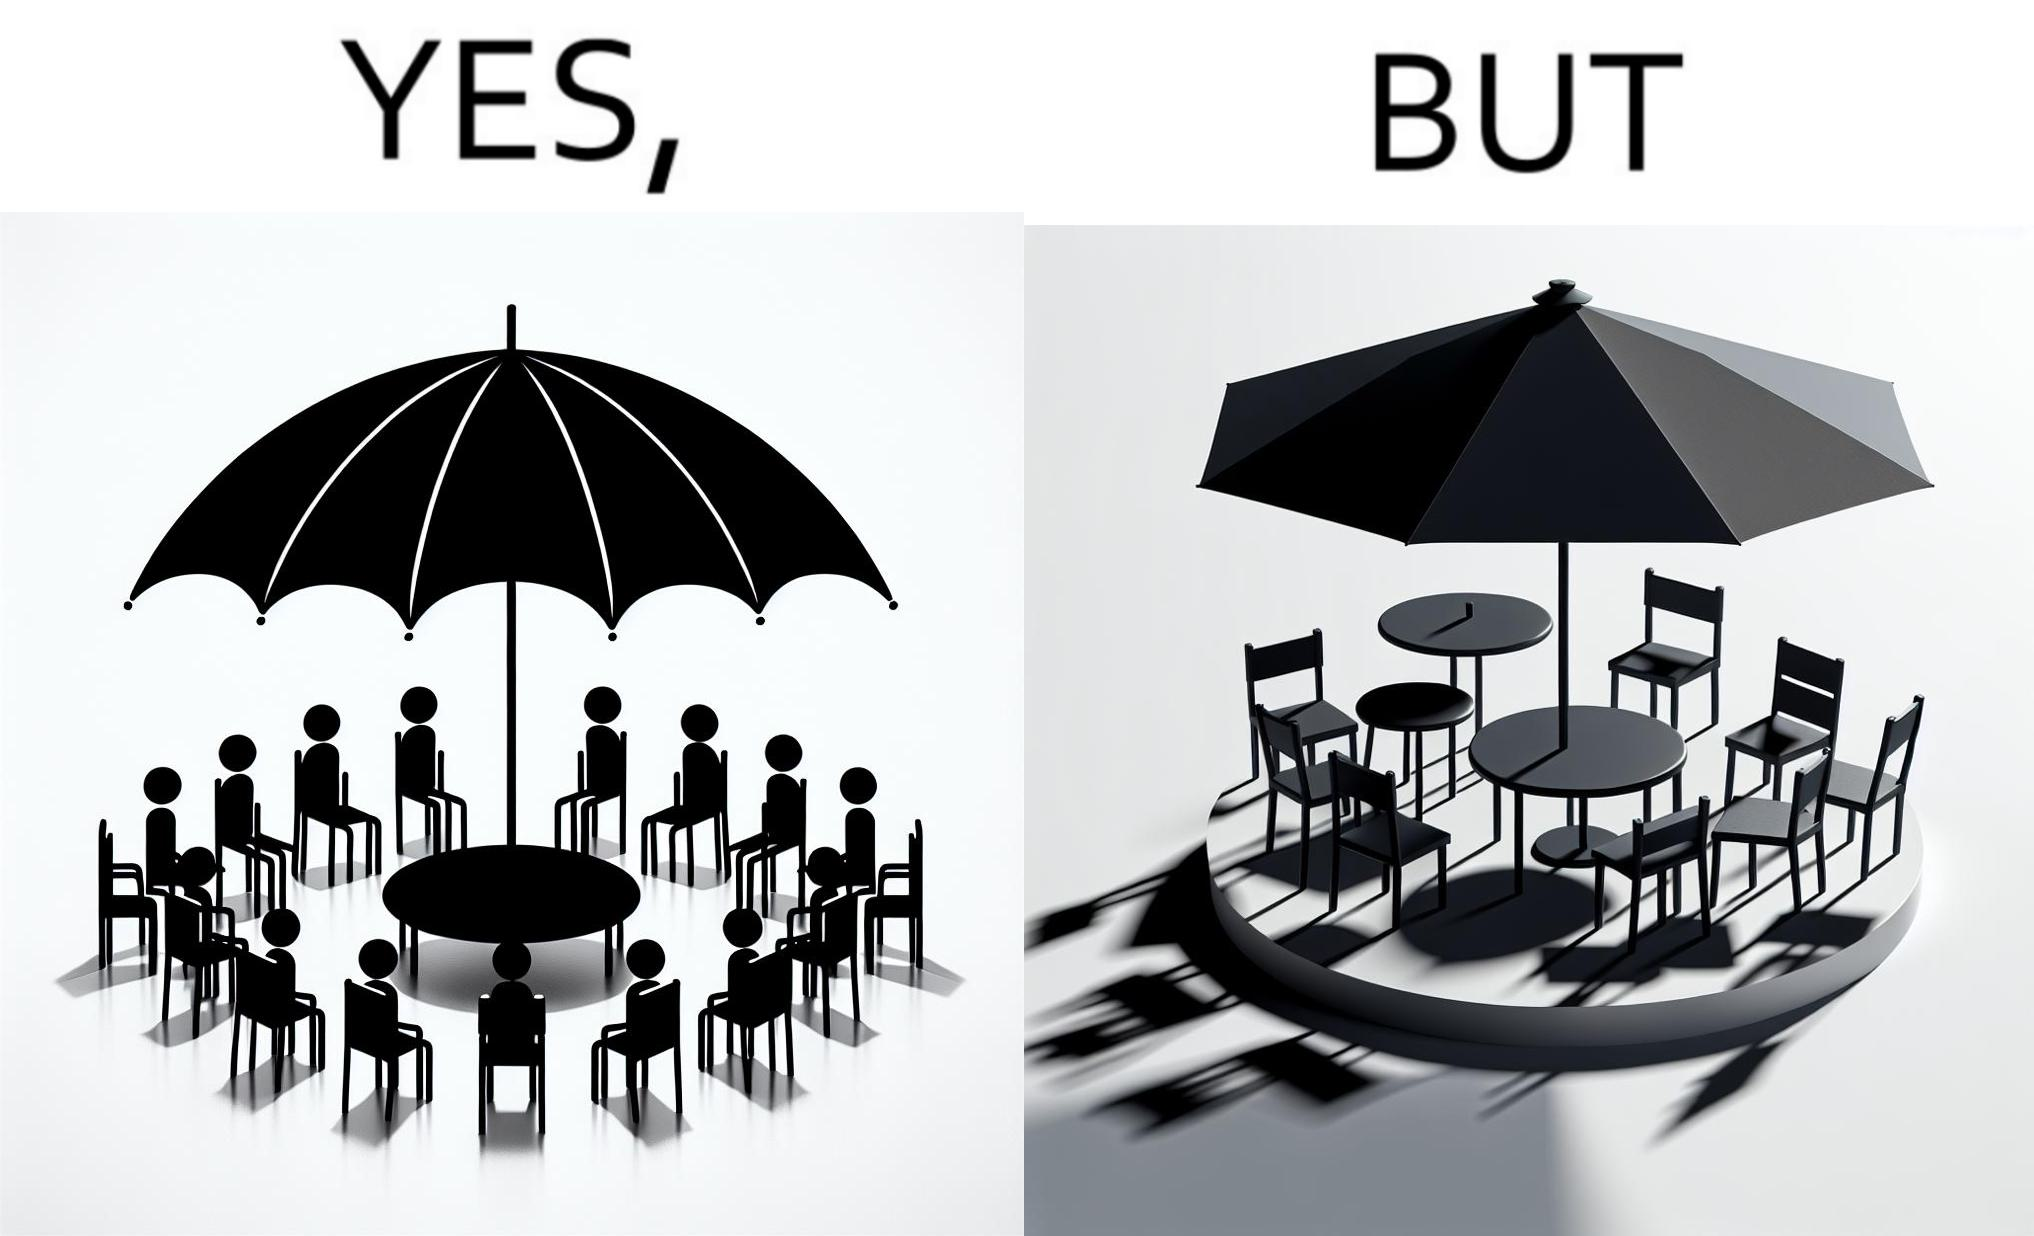Would you classify this image as satirical? Yes, this image is satirical. 